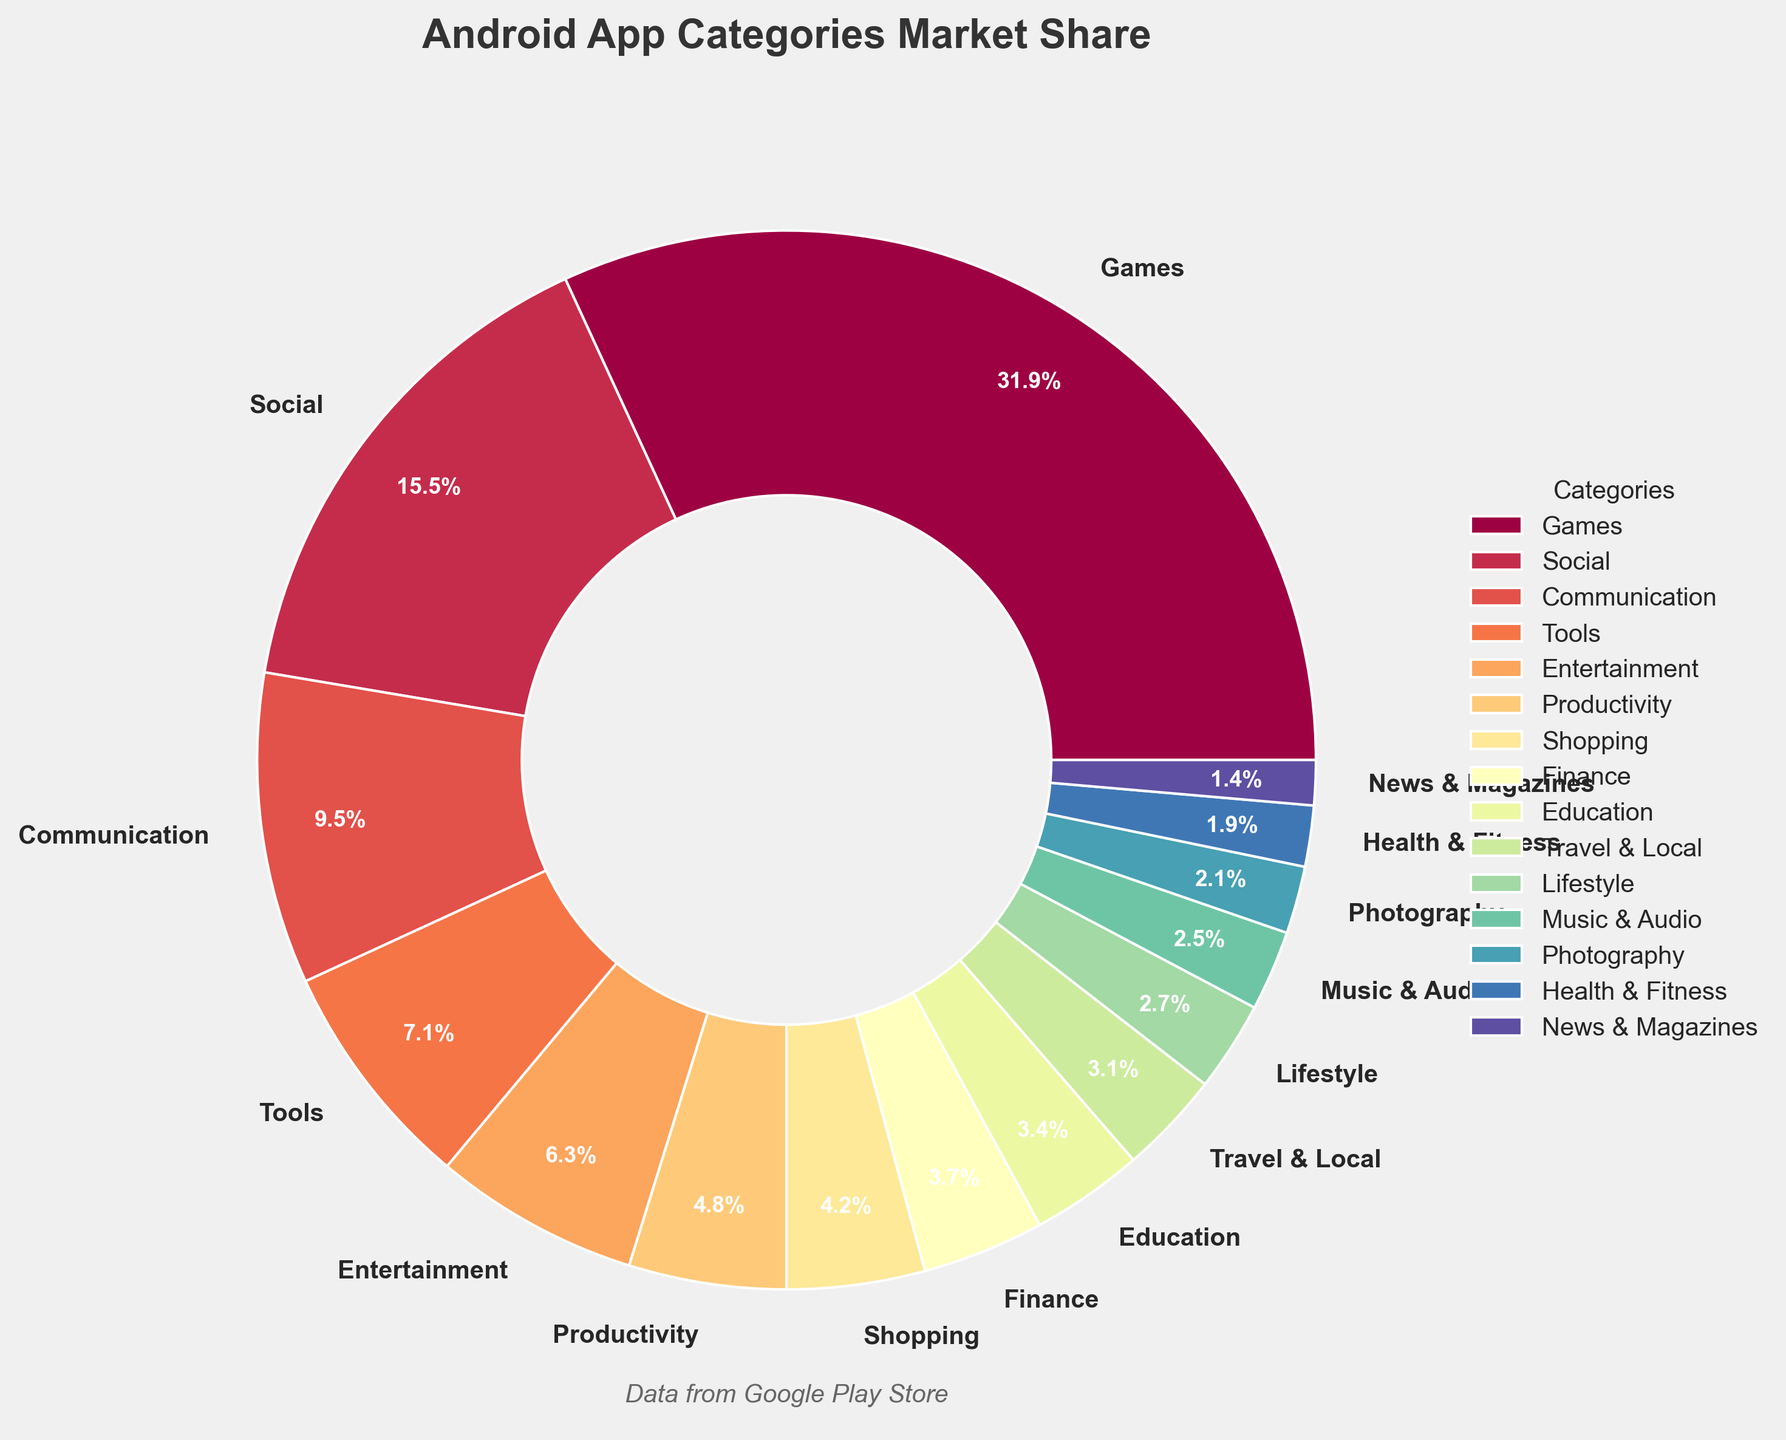What's the most popular Android app category by market share? The figure shows the market share of various Android app categories. By looking at the figure, the category with the largest market share can be identified visually by the largest segment.
Answer: Games Which category has a market share closest to 5%? To determine the category with a market share closest to 5%, compare each segment's market share and find the closest value to 5%.
Answer: Productivity How much more market share does the Games category have than the Music & Audio category? The market share of Games is 32.5%, and the market share of Music & Audio is 2.5%. Subtract the latter from the former: 32.5 - 2.5 = 30
Answer: 30% How many categories have a market share of more than 10% each? By looking at the chart, check the market share percentages of each category, and count how many are greater than 10%.
Answer: 2 categories Which three categories have the smallest market shares, and what are their respective percentages? Identify the smallest segments by market share on the pie chart. The three smallest are News & Magazines, Health & Fitness, and Photography, with respective market shares of 1.4%, 1.9%, and 2.1%.
Answer: News & Magazines (1.4%), Health & Fitness (1.9%), Photography (2.1%) What is the total market share of the top three categories? The top three categories by market share are Games (32.5%), Social (15.8%), and Communication (9.7%). Adding these gives a total market share of 32.5 + 15.8 + 9.7 = 58.
Answer: 58% Which category has a greater market share: Travel & Local or Education? Compare the market shares of Travel & Local (3.2%) and Education (3.5%). Identify the one with the greater value.
Answer: Education How does the market share of Shopping compare to Finance, and by how much? The market share of Shopping is 4.3%, and Finance is 3.8%. Subtract the smaller from the larger: 4.3 - 3.8 = 0.5
Answer: Shopping has 0.5% more What are the market shares of the categories represented by the first three colors from the top of the pie chart legend? The pie chart legend lists categories along with their corresponding colors. Identify the first three categories from the legend and refer to the figure to find their market shares: top three categories are Games (32.5%), Social (15.8%), and Communication (9.7%).
Answer: Games (32.5%), Social (15.8%), Communication (9.7%) What categories fall below the 3% market share threshold? Examine the pie chart for categories that have market shares less than 3%: Health & Fitness (1.9%), News & Magazines (1.4%), Photography (2.1%), and Music & Audio (2.5%), Lifestyle (2.8%).
Answer: Health & Fitness, News & Magazines, Photography, Music & Audio, Lifestyle 